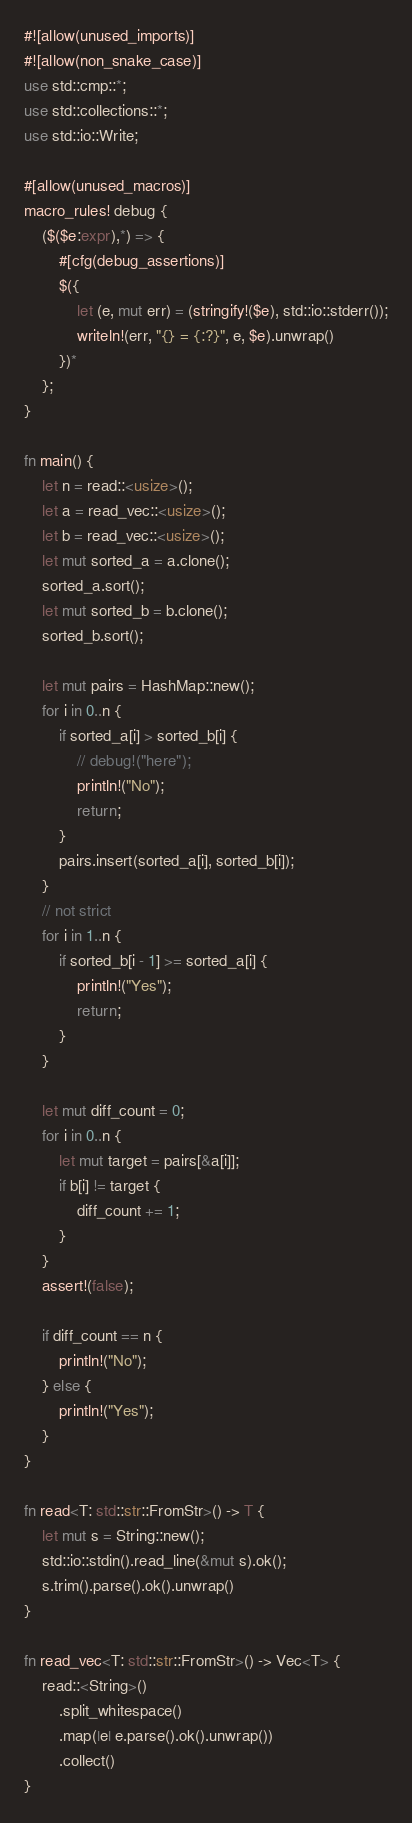Convert code to text. <code><loc_0><loc_0><loc_500><loc_500><_Rust_>#![allow(unused_imports)]
#![allow(non_snake_case)]
use std::cmp::*;
use std::collections::*;
use std::io::Write;

#[allow(unused_macros)]
macro_rules! debug {
    ($($e:expr),*) => {
        #[cfg(debug_assertions)]
        $({
            let (e, mut err) = (stringify!($e), std::io::stderr());
            writeln!(err, "{} = {:?}", e, $e).unwrap()
        })*
    };
}

fn main() {
    let n = read::<usize>();
    let a = read_vec::<usize>();
    let b = read_vec::<usize>();
    let mut sorted_a = a.clone();
    sorted_a.sort();
    let mut sorted_b = b.clone();
    sorted_b.sort();

    let mut pairs = HashMap::new();
    for i in 0..n {
        if sorted_a[i] > sorted_b[i] {
            // debug!("here");
            println!("No");
            return;
        }
        pairs.insert(sorted_a[i], sorted_b[i]);
    }
    // not strict
    for i in 1..n {
        if sorted_b[i - 1] >= sorted_a[i] {
            println!("Yes");
            return;
        }
    }

    let mut diff_count = 0;
    for i in 0..n {
        let mut target = pairs[&a[i]];
        if b[i] != target {
            diff_count += 1;
        }
    }
    assert!(false);

    if diff_count == n {
        println!("No");
    } else {
        println!("Yes");
    }
}

fn read<T: std::str::FromStr>() -> T {
    let mut s = String::new();
    std::io::stdin().read_line(&mut s).ok();
    s.trim().parse().ok().unwrap()
}

fn read_vec<T: std::str::FromStr>() -> Vec<T> {
    read::<String>()
        .split_whitespace()
        .map(|e| e.parse().ok().unwrap())
        .collect()
}
</code> 